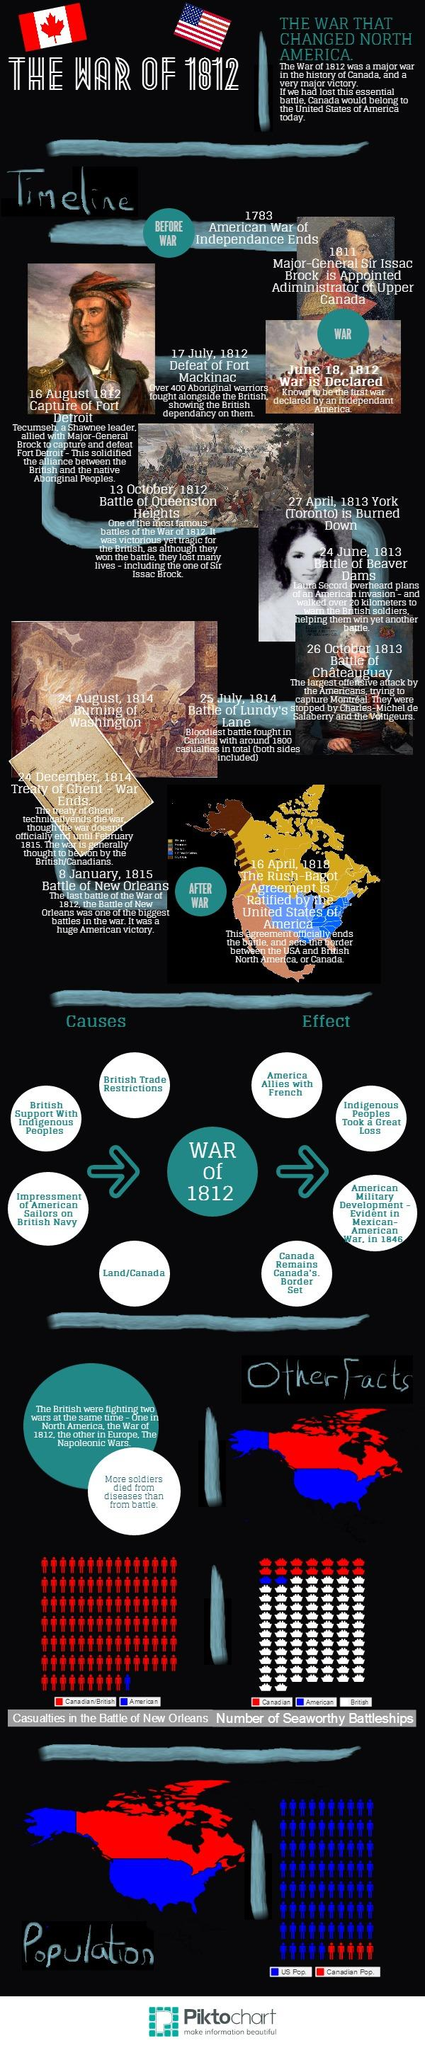Outline some significant characteristics in this image. During the War of 1812 and the Napoleonic Wars, the British were simultaneously engaged in two conflicts. The Battle of Lundy's Lane in 1814 resulted in significant casualties on both sides, with an approximate number of casualties unknown. The British Navy impressed American sailors who were forced to serve against their will. The war was declared on June 18, 1812. The Battle of New Orleans took place on January 8, 1815. 